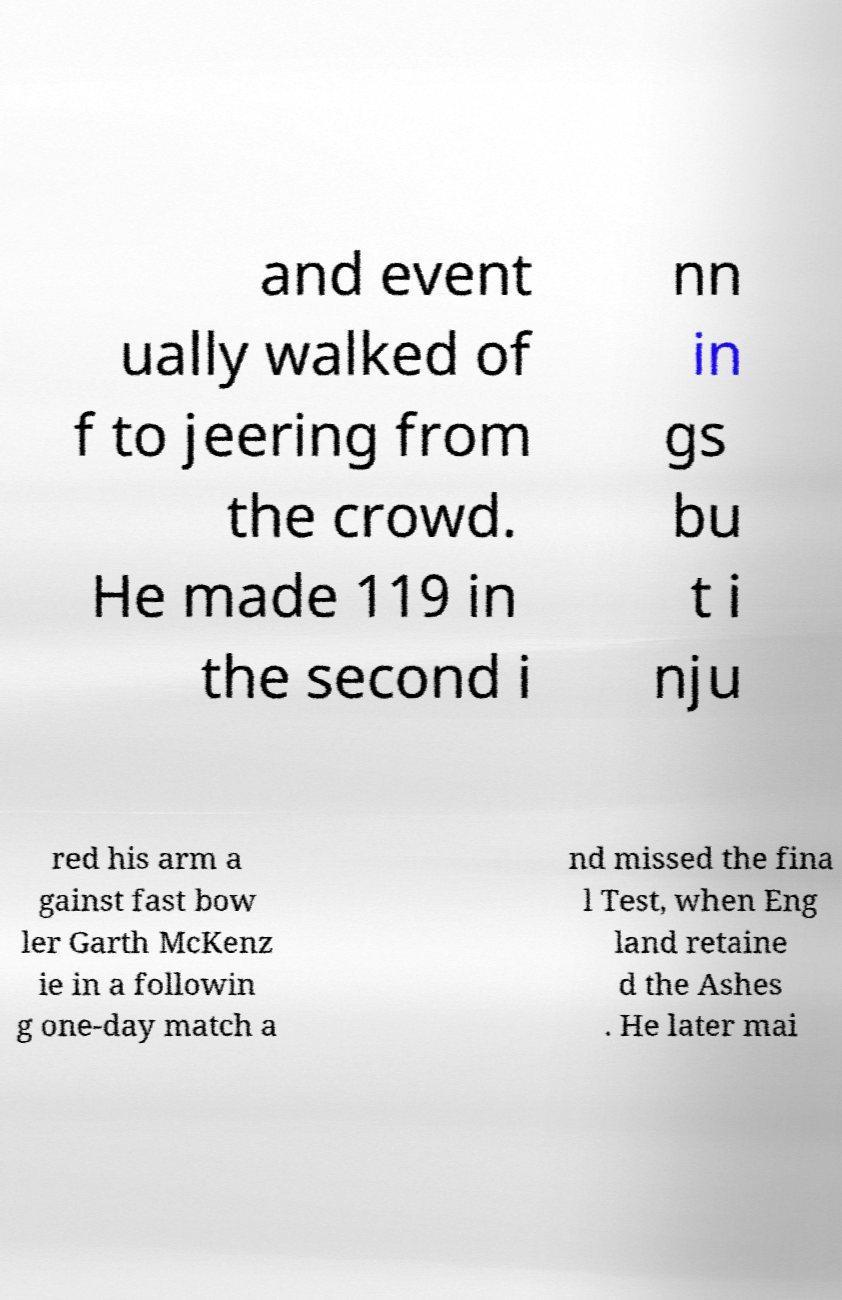Please read and relay the text visible in this image. What does it say? and event ually walked of f to jeering from the crowd. He made 119 in the second i nn in gs bu t i nju red his arm a gainst fast bow ler Garth McKenz ie in a followin g one-day match a nd missed the fina l Test, when Eng land retaine d the Ashes . He later mai 